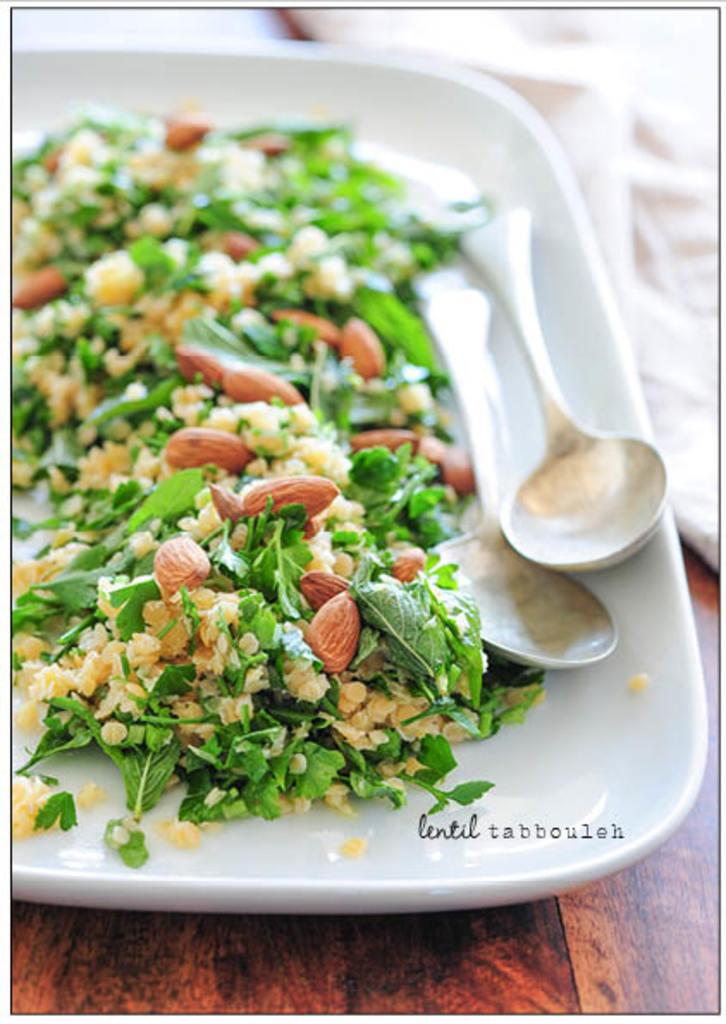What is the main subject of the image? There is a food item in the image. How many spoons are present in the image? Two spoons are present in the image. What color is the plate that holds the food item and spoons? The plate is kept on a white color plate. What type of surface is the plate placed on? The plate is placed on a wooden surface. Where is the faucet located in the image? There is no faucet present in the image. What type of school is depicted in the image? There is no school depicted in the image. 